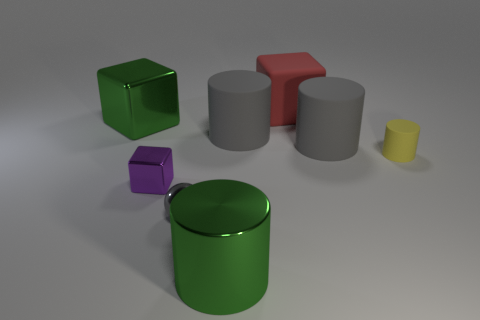What shape is the small gray object that is the same material as the large green cylinder?
Your answer should be compact. Sphere. Are there an equal number of yellow cylinders behind the big green metallic cube and large gray balls?
Ensure brevity in your answer.  Yes. There is a large green shiny object in front of the small yellow cylinder; are there any big gray matte things on the right side of it?
Your answer should be compact. Yes. Are there any other things that are the same color as the tiny cube?
Your answer should be very brief. No. Is the large cube that is to the left of the green metallic cylinder made of the same material as the small gray ball?
Make the answer very short. Yes. Is the number of matte blocks that are in front of the tiny purple metal object the same as the number of small matte cylinders that are behind the big green cylinder?
Your response must be concise. No. What size is the metal cube right of the big green shiny thing behind the large metal cylinder?
Provide a succinct answer. Small. The tiny thing that is both on the left side of the large red cube and to the right of the purple shiny object is made of what material?
Your answer should be very brief. Metal. What number of other objects are there of the same size as the metallic cylinder?
Your response must be concise. 4. The small sphere is what color?
Your answer should be compact. Gray. 